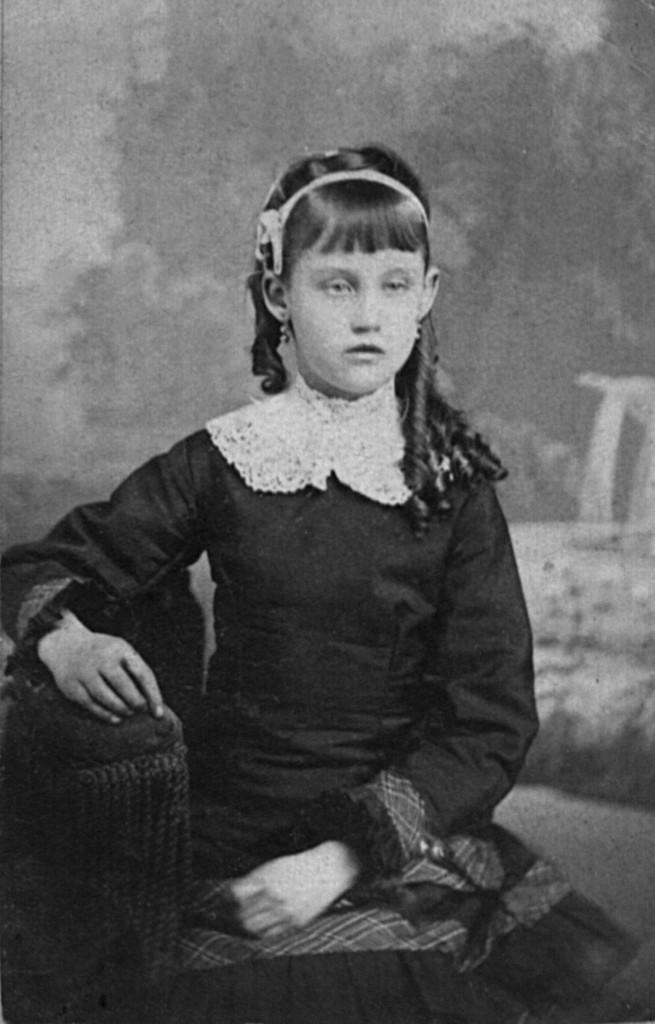What is the color scheme of the image? The image is black and white. What can be seen in the image? There is a girl sitting in the image. What type of vein is visible on the girl's arm in the image? There is no visible vein on the girl's arm in the image, as it is a black and white photograph. Is the girl crying in the image? There is no indication of the girl crying in the image; she is simply sitting. 